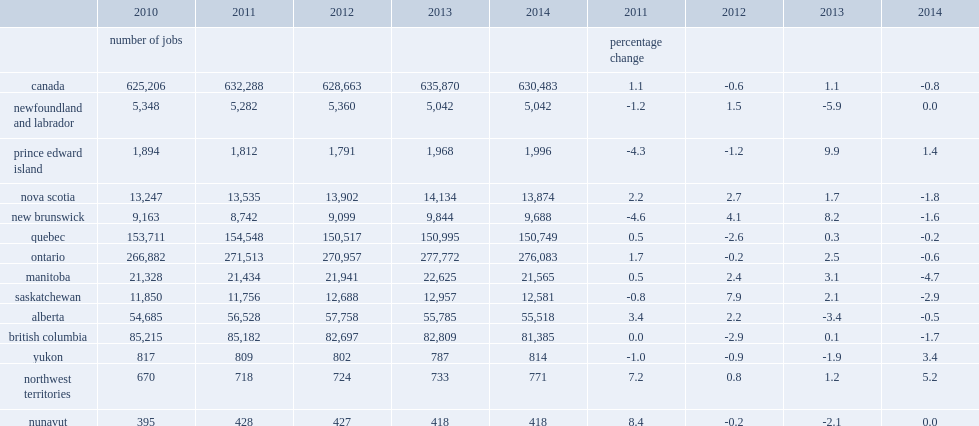What was the percentage of culture jobs in newfoundland and labrador decline in 2013? 5.9. What was the percentage of culture jobs in prince edward island rose in 2014? 1.4. What was the percentage of culture jobs in prince edward island rose in 2013? 9.9. What was the percentgae of culture jobs in nova scotia declined in 2014? 1.8. What was the percentgae of culture jobs in new brunswick declined in 2014? 1.6. What was the percentgae of culture jobs in new brunswick increased in 2013? 8.2. What was the percentgae of culture jobs in quebec declined in 2014? 0.2. What was the percentgae of culture jobs in quebec increased in 2013? 0.3. What was the percentgae of culture jobs in ontario declined in 2014? 0.6. What was the percentgae of culture jobs in ontario increased in 2013? 2.5. What was the percentgae of culture jobs in manitoba decreased in 2014? 4.7. What was the percentgae of culture jobs in manitoba increased in 2013? 3.1. What was the percentgae of culture jobs in saskatchewan decreased in 2014? 2.9. What was the percentgae of culture jobs in saskatchewan increased in 2013? 2.1. What was the percentgae of culture jobs in alberta receded in 2014? 0.5. What was the percentgae of culture jobs in alberta decreased in 2013? 3.4. What was the percentgae of culture jobs in british columbia declined in 2014? 1.7. What was the percentgae of culture jobs in british columbia edged up in 2013? 0.1. What was the percentgae of culture jobs in yukon increased in 2014? 3.4. What was the percentgae of culture jobs in northwest territories increased in 2014? 5.2. What was the percentgae of culture jobs in northwest territories increased in 2013? 1.2. What was the percentgae of culture jobs in nunavut declined in 2013? 2.1. 